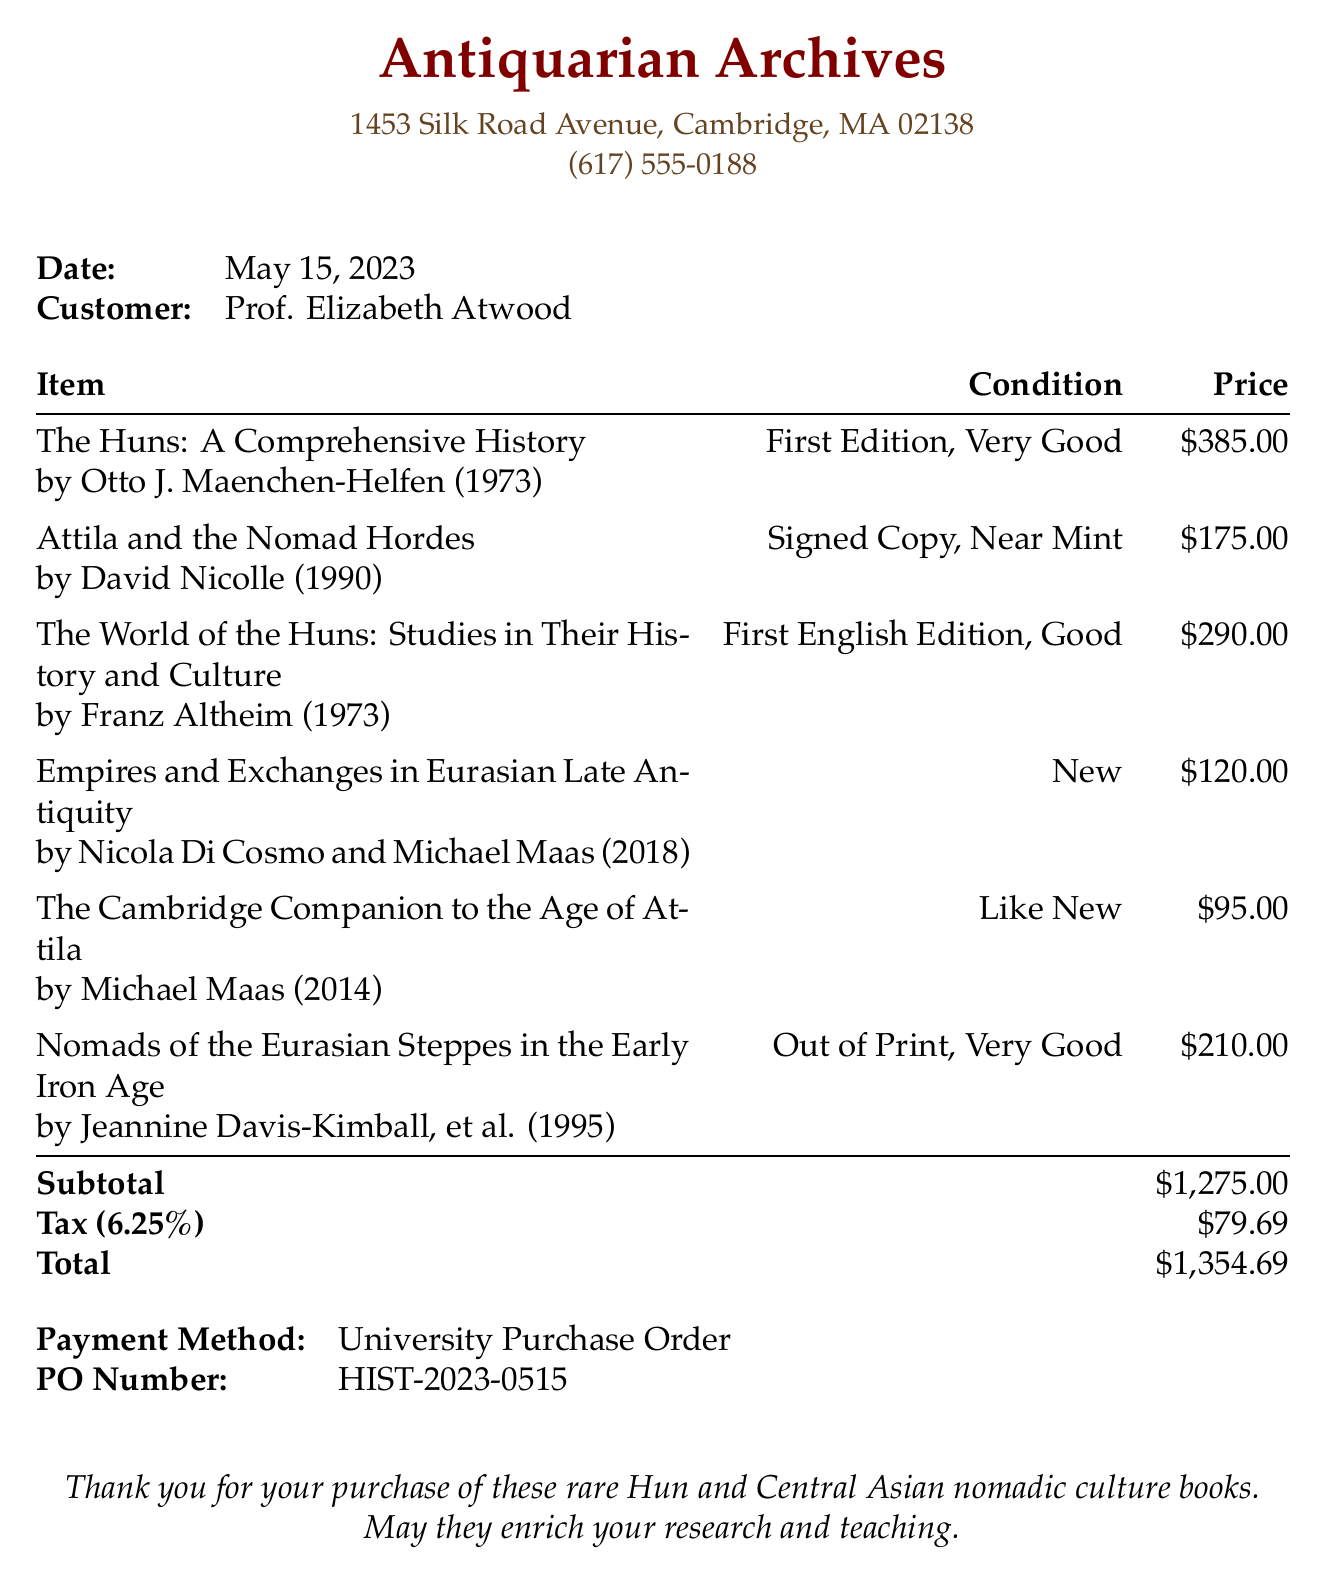What is the name of the bookstore? The name of the bookstore is stated at the top of the receipt.
Answer: Antiquarian Archives What is the address of the bookstore? The address is listed in the contact details section of the receipt.
Answer: 1453 Silk Road Avenue, Cambridge, MA 02138 Who is the customer? The customer's name is specifically mentioned in the receipt details.
Answer: Prof. Elizabeth Atwood What is the condition of "The Huns: A Comprehensive History"? The condition is specified directly under the title in the itemized section.
Answer: First Edition, Very Good What total amount was paid? The total is clearly indicated at the bottom of the receipt.
Answer: $1,354.69 How many items were purchased? The number of items can be counted in the itemized section of the receipt.
Answer: 6 What payment method was used? The payment method is specifically mentioned toward the end of the receipt.
Answer: University Purchase Order Which item has a signed copy? The title of the item with a signed copy is indicated in the item list.
Answer: Attila and the Nomad Hordes What year was "The World of the Huns" published? The year of publication is listed next to the title in the item description.
Answer: 1973 What is the PO number? The PO number is explicitly mentioned in the payment details section.
Answer: HIST-2023-0515 